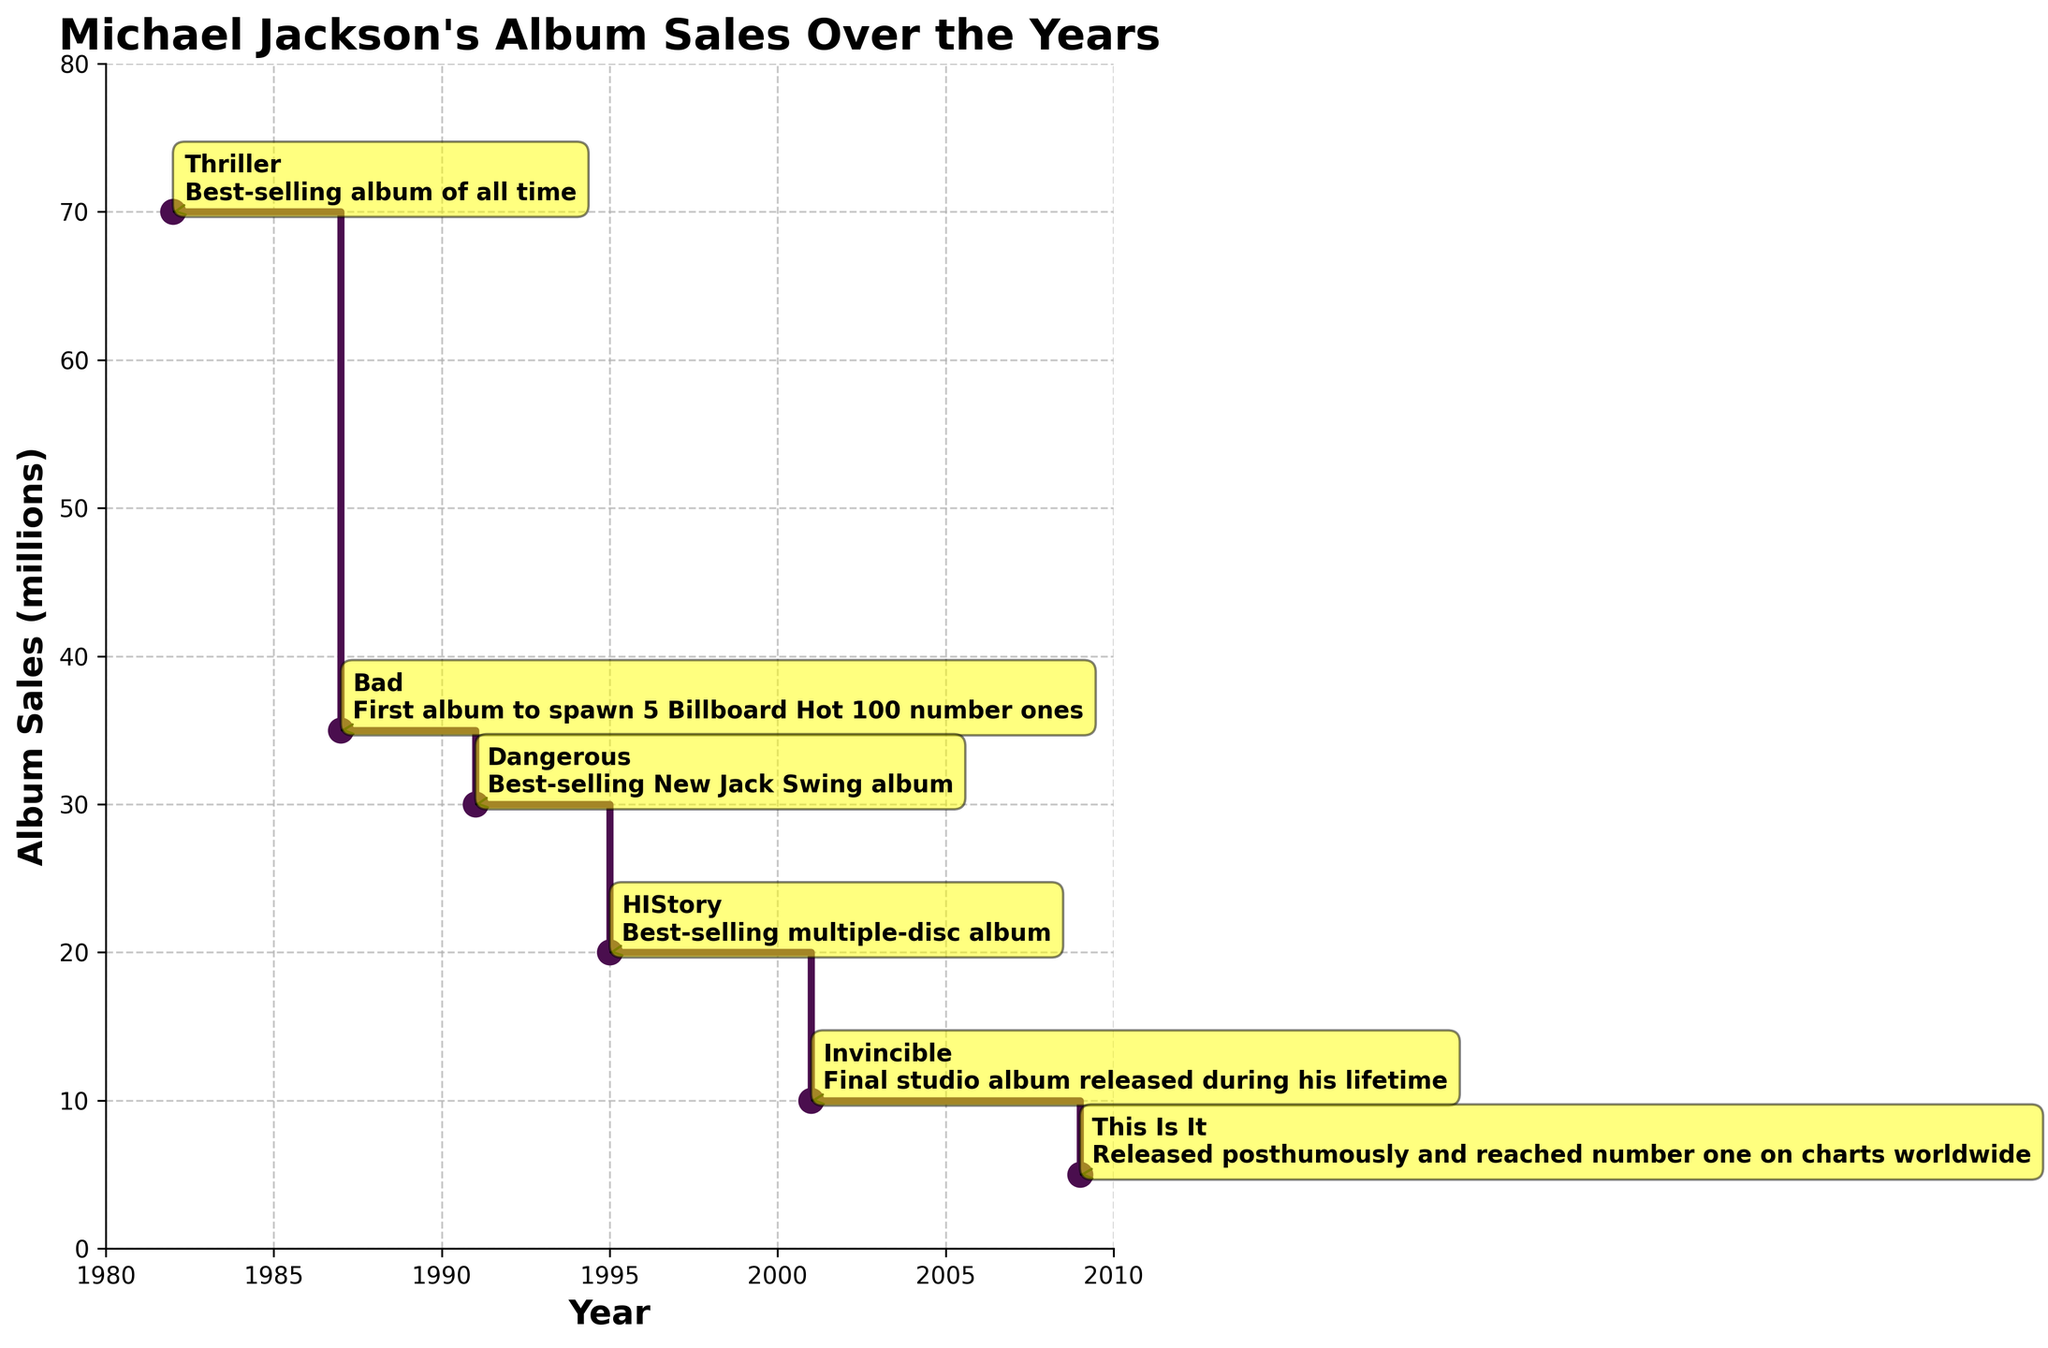How many albums are represented in the figure? Count the number of unique points on the plot connected by the stair-like segments.
Answer: 6 What is the title of the figure? The title is located at the top of the plot.
Answer: Michael Jackson's Album Sales Over the Years In which year did Michael Jackson release the album with the highest sales? Look at the year corresponding to the highest point on the sales axis.
Answer: 1982 Which album was released posthumously? Find the annotation with the milestone mentioning posthumous release.
Answer: This Is It What was the total album sales in millions up to 2001? Add the sales for all albums released up to 2001 (70 + 35 + 30 + 20 + 10).
Answer: 165 Between which two adjacent years did Michael Jackson's album sales see the largest drop? Compare the differences between sales values of consecutive years and identify the largest drop.
Answer: 1995 to 2001 Which album is annotated with the milestone "Best-selling New Jack Swing album"? Look at the annotations and find the album with this milestone.
Answer: Dangerous What is the average album sales in millions for all albums represented in the plot? Sum all sales values and divide by the number of albums (170 / 6).
Answer: 28.33 Which two albums have the closest sales figures? Compare the sales values of all albums and identify the closest pair.
Answer: Bad and Dangerous What is the difference in album sales between "Thriller" and "HIStory"? Subtract the sales of HIStory from Thriller (70 - 20).
Answer: 50 